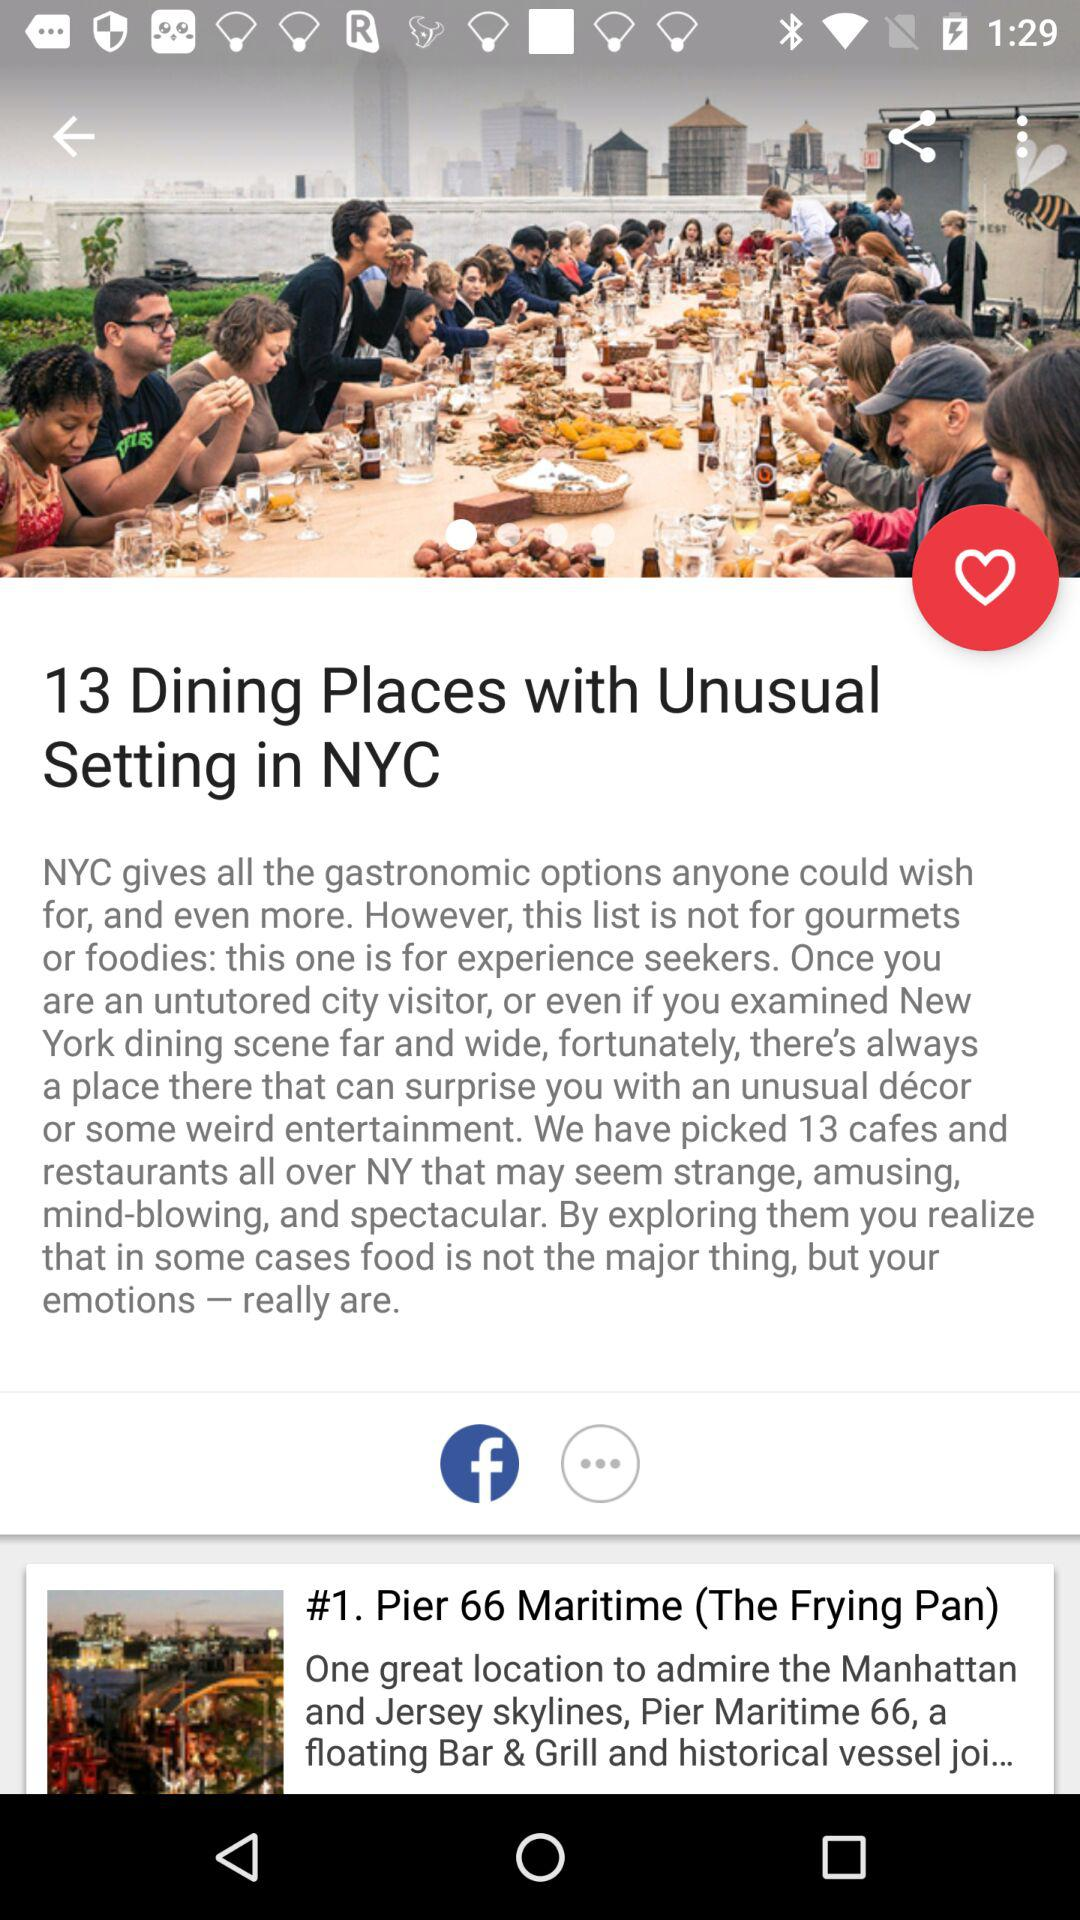How many dining places are there with unusual setting in NYC? There are 13 dining places with unusual setting in NYC. 